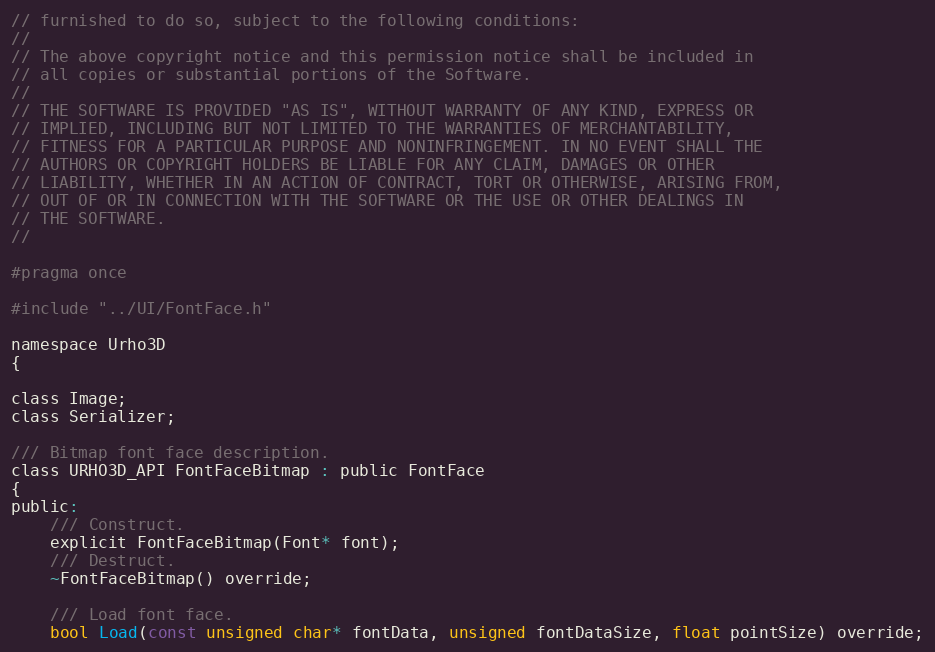Convert code to text. <code><loc_0><loc_0><loc_500><loc_500><_C_>// furnished to do so, subject to the following conditions:
//
// The above copyright notice and this permission notice shall be included in
// all copies or substantial portions of the Software.
//
// THE SOFTWARE IS PROVIDED "AS IS", WITHOUT WARRANTY OF ANY KIND, EXPRESS OR
// IMPLIED, INCLUDING BUT NOT LIMITED TO THE WARRANTIES OF MERCHANTABILITY,
// FITNESS FOR A PARTICULAR PURPOSE AND NONINFRINGEMENT. IN NO EVENT SHALL THE
// AUTHORS OR COPYRIGHT HOLDERS BE LIABLE FOR ANY CLAIM, DAMAGES OR OTHER
// LIABILITY, WHETHER IN AN ACTION OF CONTRACT, TORT OR OTHERWISE, ARISING FROM,
// OUT OF OR IN CONNECTION WITH THE SOFTWARE OR THE USE OR OTHER DEALINGS IN
// THE SOFTWARE.
//

#pragma once

#include "../UI/FontFace.h"

namespace Urho3D
{

class Image;
class Serializer;

/// Bitmap font face description.
class URHO3D_API FontFaceBitmap : public FontFace
{
public:
    /// Construct.
    explicit FontFaceBitmap(Font* font);
    /// Destruct.
    ~FontFaceBitmap() override;

    /// Load font face.
    bool Load(const unsigned char* fontData, unsigned fontDataSize, float pointSize) override;</code> 